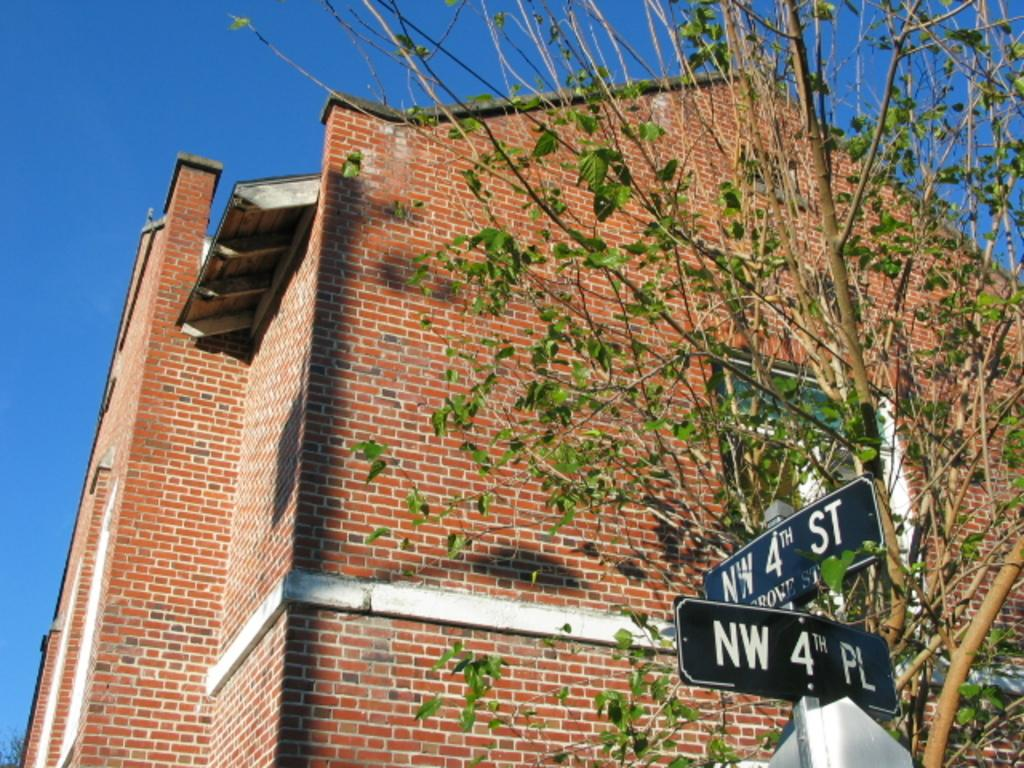Provide a one-sentence caption for the provided image. Two street signs designate the intersection of NW 4th Street and NW 4th Place. 